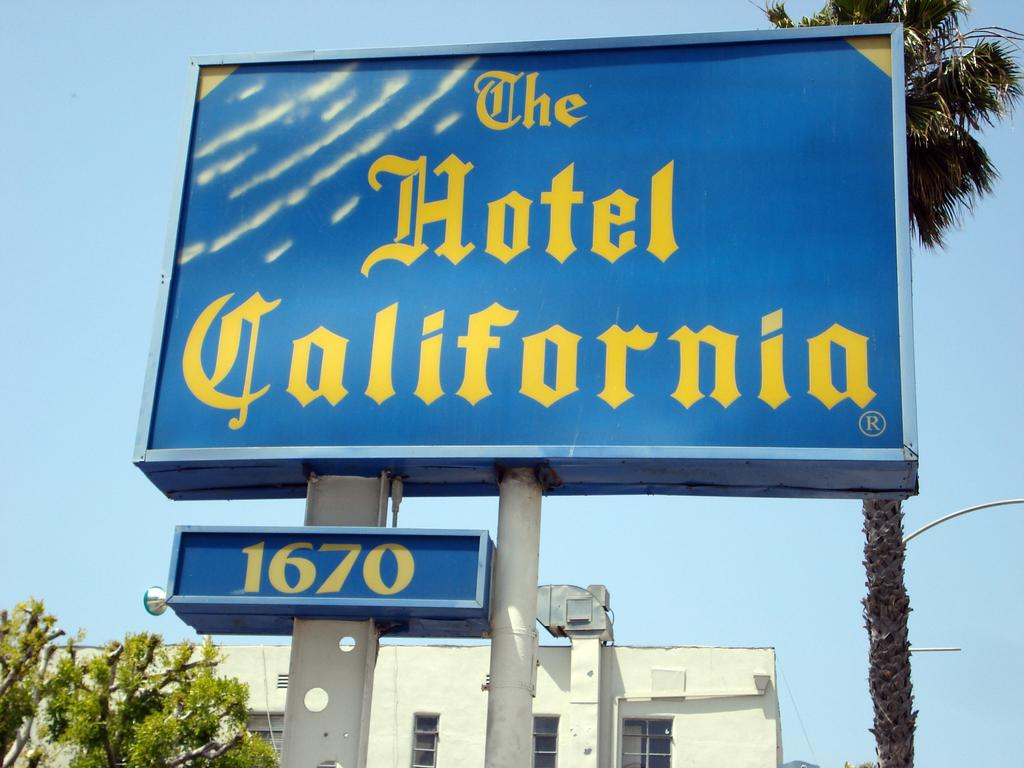<image>
Give a short and clear explanation of the subsequent image. Blue sign out doors titled The Hotel California 